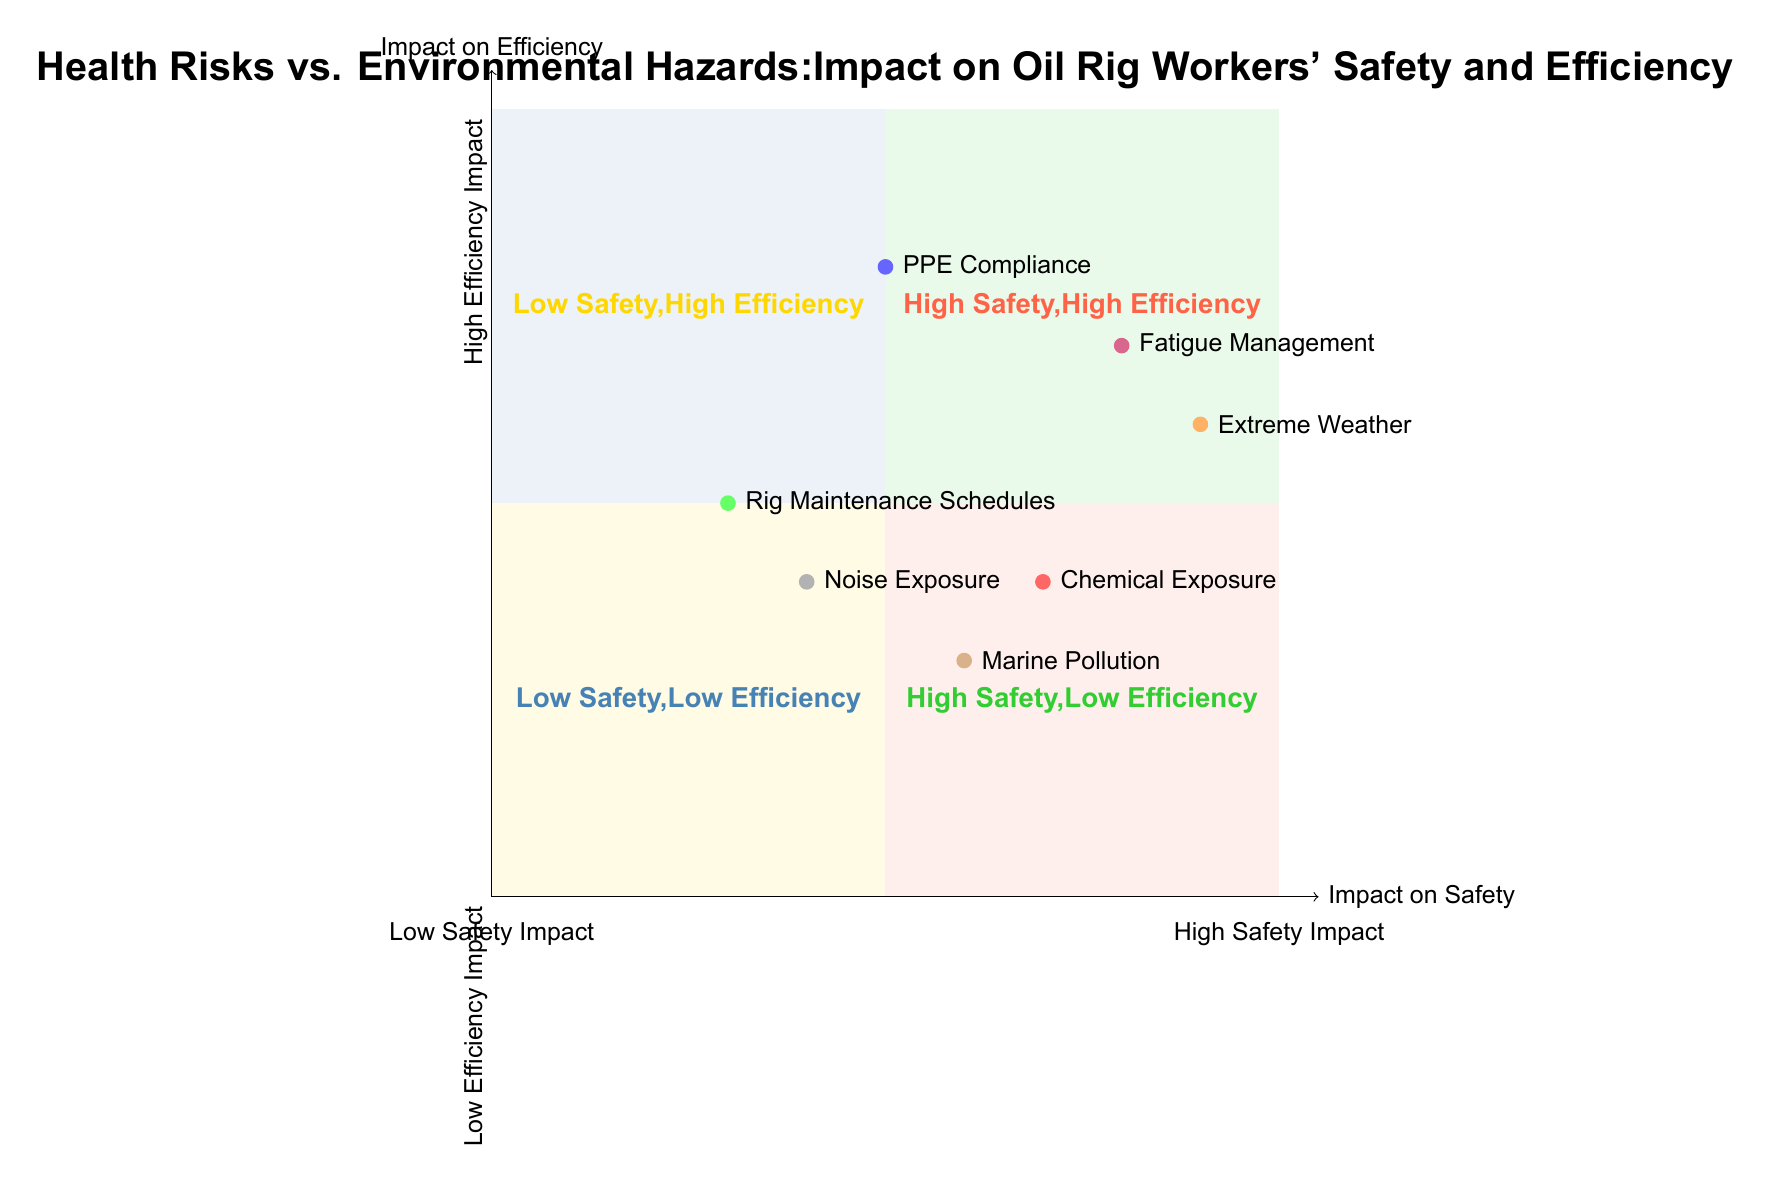What is the health risk associated with Chemical Exposure? The diagram indicates that Chemical Exposure has a high safety impact (7) and a moderate efficiency impact (4). The details mention that it can cause serious health issues.
Answer: Serious health issues What element shows the highest impact on efficiency? Among the elements plotted, Fatigue Management has the highest impact on efficiency at a value of 7, as observed on the y-axis.
Answer: Fatigue Management How many elements are plotted in the diagram? The diagram includes a total of 7 elements that represent various health risks and environmental hazards affecting oil rig workers.
Answer: 7 Which element is located in the High Safety, Low Efficiency quadrant? The diagram shows Rig Maintenance Schedules is located in the High Safety, Low Efficiency quadrant, represented by coordinates (3, 5).
Answer: Rig Maintenance Schedules What is the impact on safety for Extreme Weather? Extreme Weather is positioned at (9, 6) on the quadrant chart, indicating a high safety impact value of 9.
Answer: 9 How do the impacts of Noise Exposure compare to Marine Pollution regarding efficiency? Noise Exposure (4) is less impactful than Marine Pollution (3) in terms of efficiency based on their y-axis values, indicating both have a low impact, but Noise Exposure is higher.
Answer: Noise Exposure is higher Which element has a high safety impact but low efficiency impact according to the diagram? Based on the plotted elements, Chemical Exposure is noted to have a high safety impact (7) but a moderate efficiency impact (4).
Answer: Chemical Exposure In which quadrant is Extreme Weather located? Extreme Weather falls into the quadrant labeled as High Safety, Low Efficiency due to its coordinates of (9, 6).
Answer: High Safety, Low Efficiency 